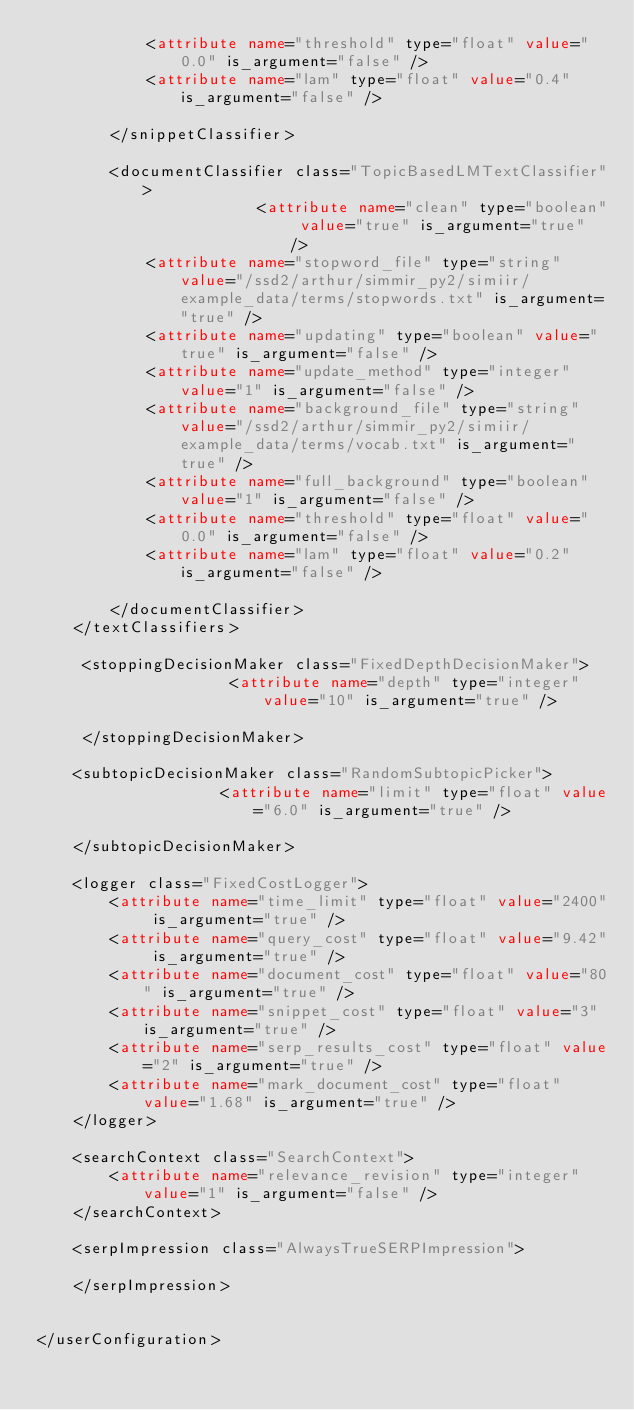<code> <loc_0><loc_0><loc_500><loc_500><_XML_>            <attribute name="threshold" type="float" value="0.0" is_argument="false" />
            <attribute name="lam" type="float" value="0.4" is_argument="false" />

        </snippetClassifier>

        <documentClassifier class="TopicBasedLMTextClassifier">
                        <attribute name="clean" type="boolean" value="true" is_argument="true" />
            <attribute name="stopword_file" type="string" value="/ssd2/arthur/simmir_py2/simiir/example_data/terms/stopwords.txt" is_argument="true" />
            <attribute name="updating" type="boolean" value="true" is_argument="false" />
            <attribute name="update_method" type="integer" value="1" is_argument="false" />
            <attribute name="background_file" type="string" value="/ssd2/arthur/simmir_py2/simiir/example_data/terms/vocab.txt" is_argument="true" />
            <attribute name="full_background" type="boolean" value="1" is_argument="false" />
            <attribute name="threshold" type="float" value="0.0" is_argument="false" />
            <attribute name="lam" type="float" value="0.2" is_argument="false" />

        </documentClassifier>
    </textClassifiers>

     <stoppingDecisionMaker class="FixedDepthDecisionMaker">
                     <attribute name="depth" type="integer" value="10" is_argument="true" />

     </stoppingDecisionMaker>

    <subtopicDecisionMaker class="RandomSubtopicPicker">
                    <attribute name="limit" type="float" value="6.0" is_argument="true" />

    </subtopicDecisionMaker>

    <logger class="FixedCostLogger">
		<attribute name="time_limit" type="float" value="2400" is_argument="true" />
		<attribute name="query_cost" type="float" value="9.42" is_argument="true" />
		<attribute name="document_cost" type="float" value="80" is_argument="true" />
		<attribute name="snippet_cost" type="float" value="3" is_argument="true" />
		<attribute name="serp_results_cost" type="float" value="2" is_argument="true" />
		<attribute name="mark_document_cost" type="float" value="1.68" is_argument="true" />
	</logger>

	<searchContext class="SearchContext">
		<attribute name="relevance_revision" type="integer" value="1" is_argument="false" />
	</searchContext>

	<serpImpression class="AlwaysTrueSERPImpression">
        
	</serpImpression>


</userConfiguration></code> 